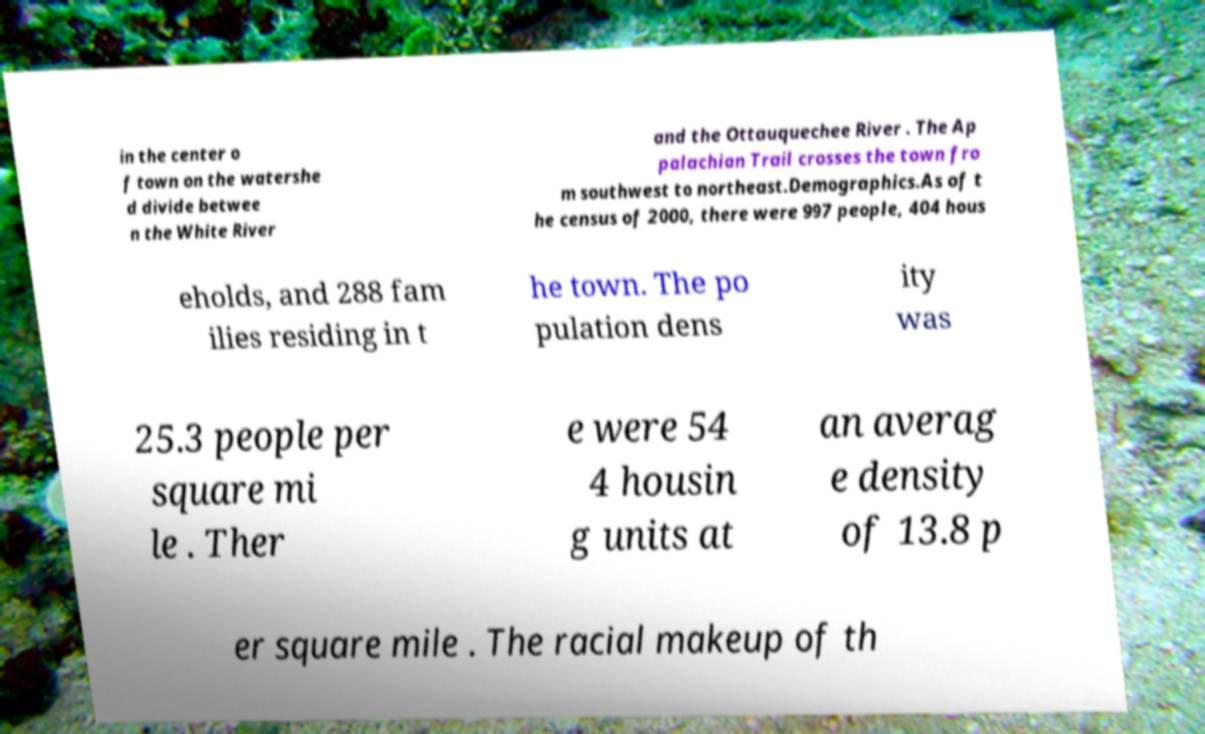What messages or text are displayed in this image? I need them in a readable, typed format. in the center o f town on the watershe d divide betwee n the White River and the Ottauquechee River . The Ap palachian Trail crosses the town fro m southwest to northeast.Demographics.As of t he census of 2000, there were 997 people, 404 hous eholds, and 288 fam ilies residing in t he town. The po pulation dens ity was 25.3 people per square mi le . Ther e were 54 4 housin g units at an averag e density of 13.8 p er square mile . The racial makeup of th 